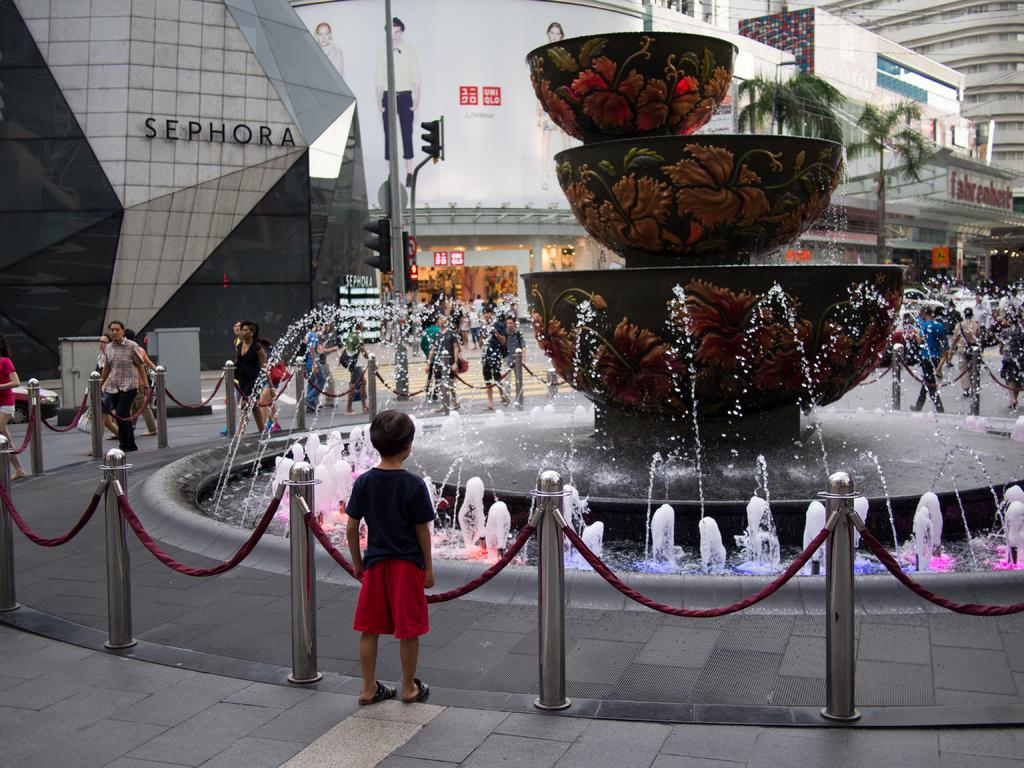<image>
Create a compact narrative representing the image presented. the word sephora is on a large building 